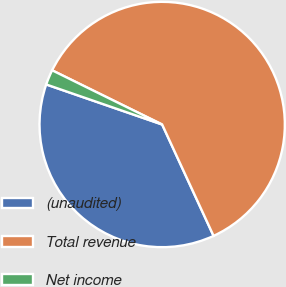<chart> <loc_0><loc_0><loc_500><loc_500><pie_chart><fcel>(unaudited)<fcel>Total revenue<fcel>Net income<nl><fcel>37.18%<fcel>60.84%<fcel>1.99%<nl></chart> 